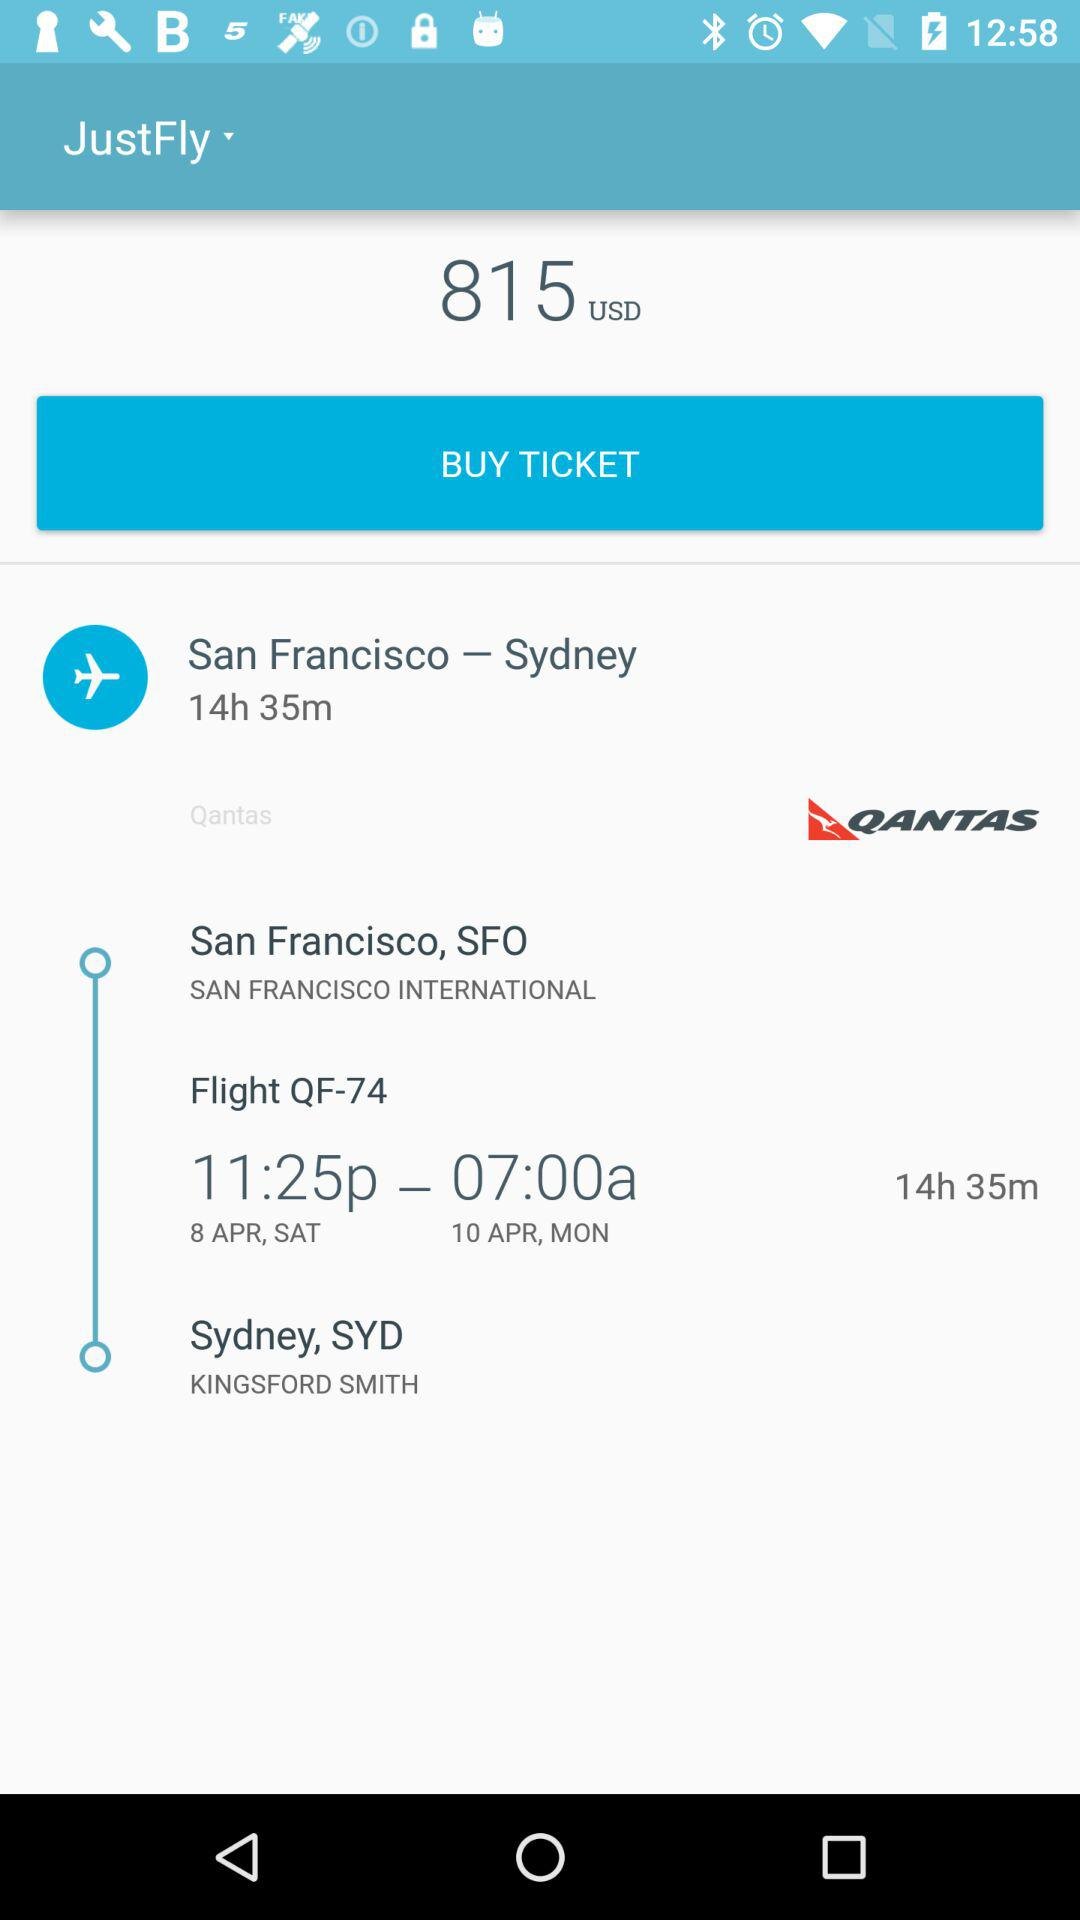How many hours is the flight?
Answer the question using a single word or phrase. 14h 35m 